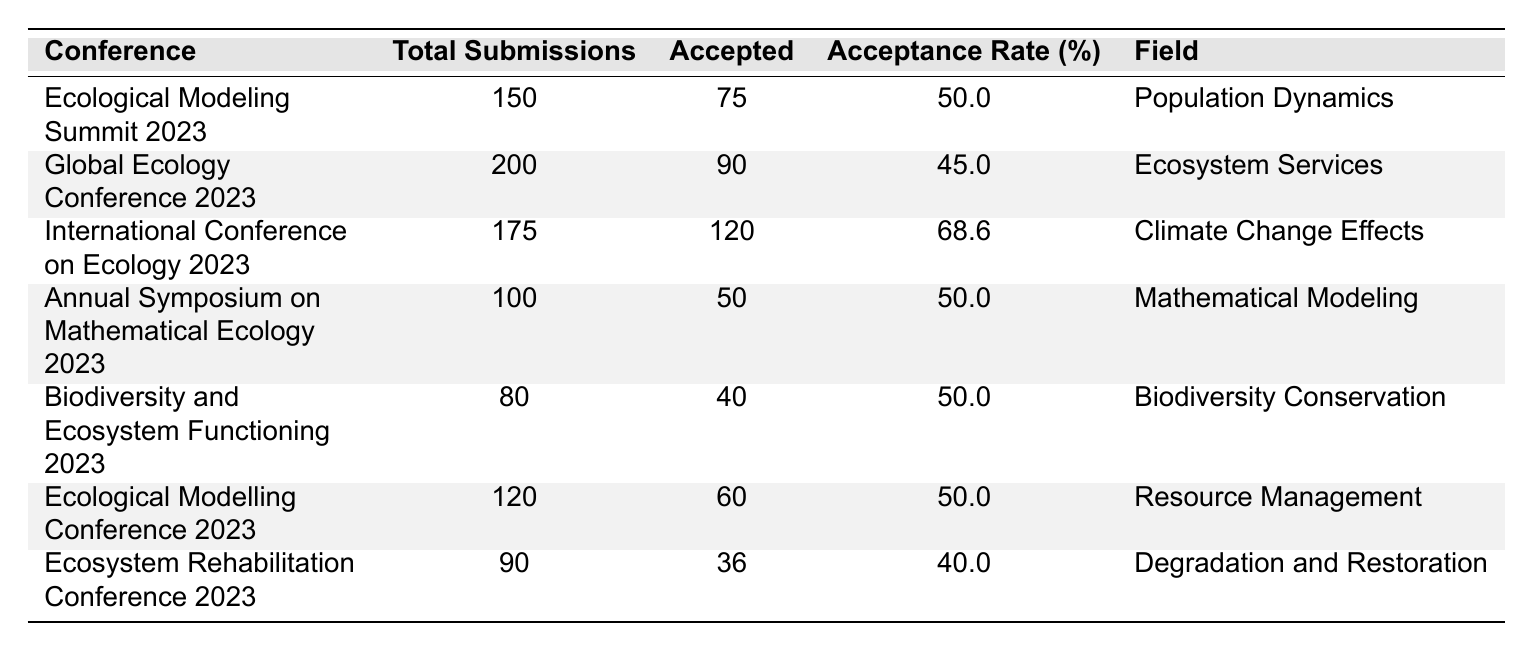What is the acceptance rate for the International Conference on Ecology 2023? The table states that the acceptance rate for the International Conference on Ecology 2023 is 68.6%.
Answer: 68.6% Which conference had the highest number of total submissions? According to the table, the Global Ecology Conference 2023 had the highest total submissions at 200.
Answer: 200 How many total submissions were accepted for the Annual Symposium on Mathematical Ecology 2023? The table indicates that the Annual Symposium on Mathematical Ecology 2023 accepted 50 submissions.
Answer: 50 Is the acceptance rate for the Ecosystem Rehabilitation Conference 2023 higher than 40%? The table shows that the acceptance rate for the Ecosystem Rehabilitation Conference 2023 is 40%, which means it is not higher than 40%.
Answer: No What is the average acceptance rate of all the conferences listed in the table? First, add the acceptance rates: 50.0 + 45.0 + 68.6 + 50.0 + 50.0 + 50.0 + 40.0 = 393.6. Then, divide by the number of conferences (7): 393.6 / 7 = 56.3.
Answer: 56.3 Which field had the least number of accepted submissions? By reviewing the accepted submissions across fields, the Ecosystem Rehabilitation Conference 2023 had the least at 36 accepted submissions.
Answer: 36 If we exclude the field of Mathematical Modeling, what is the total number of accepted submissions across the remaining conferences? The accepted submissions excluding Mathematical Modeling are: 75 + 90 + 120 + 40 + 60 + 36 = 411.
Answer: 411 Which conference had both the highest acceptance rate and the highest total submissions combined? The International Conference on Ecology 2023 has the highest acceptance rate at 68.6% and also has a high number of total submissions at 175. By examining the total submissions and accepted rates, it stands out in both areas.
Answer: International Conference on Ecology 2023 How many conferences have an acceptance rate of exactly 50%? The table reveals that three conferences (Ecological Modeling Summit 2023, Annual Symposium on Mathematical Ecology 2023, and Biodiversity and Ecosystem Functioning 2023) have an acceptance rate of exactly 50%.
Answer: 3 